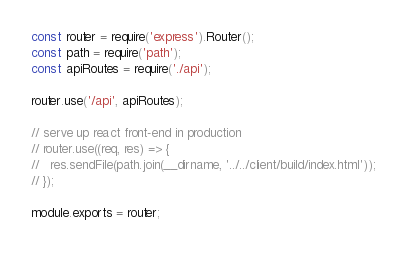Convert code to text. <code><loc_0><loc_0><loc_500><loc_500><_JavaScript_>const router = require('express').Router();
const path = require('path');
const apiRoutes = require('./api');

router.use('/api', apiRoutes);

// serve up react front-end in production
// router.use((req, res) => {
//   res.sendFile(path.join(__dirname, '../../client/build/index.html'));
// });

module.exports = router;
</code> 